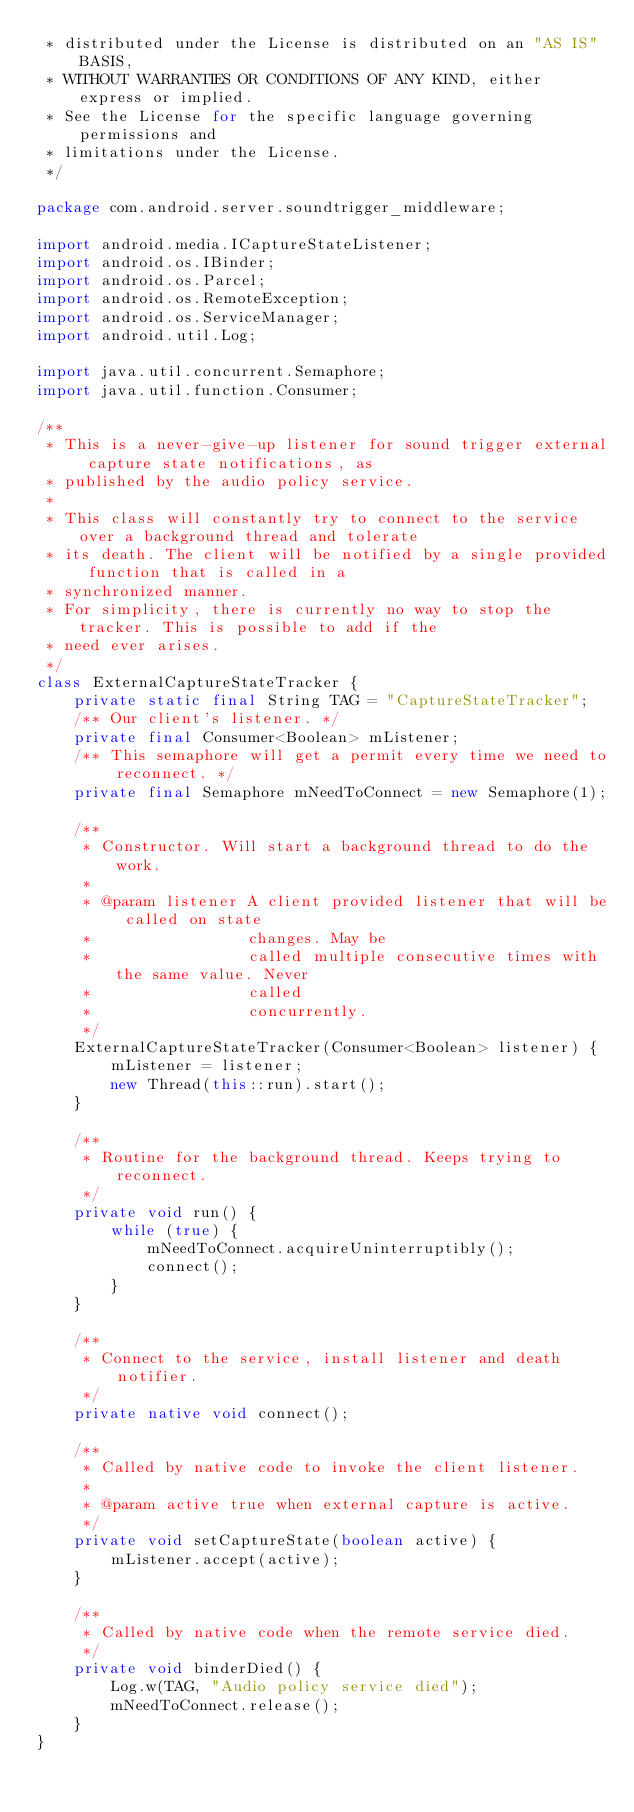<code> <loc_0><loc_0><loc_500><loc_500><_Java_> * distributed under the License is distributed on an "AS IS" BASIS,
 * WITHOUT WARRANTIES OR CONDITIONS OF ANY KIND, either express or implied.
 * See the License for the specific language governing permissions and
 * limitations under the License.
 */

package com.android.server.soundtrigger_middleware;

import android.media.ICaptureStateListener;
import android.os.IBinder;
import android.os.Parcel;
import android.os.RemoteException;
import android.os.ServiceManager;
import android.util.Log;

import java.util.concurrent.Semaphore;
import java.util.function.Consumer;

/**
 * This is a never-give-up listener for sound trigger external capture state notifications, as
 * published by the audio policy service.
 *
 * This class will constantly try to connect to the service over a background thread and tolerate
 * its death. The client will be notified by a single provided function that is called in a
 * synchronized manner.
 * For simplicity, there is currently no way to stop the tracker. This is possible to add if the
 * need ever arises.
 */
class ExternalCaptureStateTracker {
    private static final String TAG = "CaptureStateTracker";
    /** Our client's listener. */
    private final Consumer<Boolean> mListener;
    /** This semaphore will get a permit every time we need to reconnect. */
    private final Semaphore mNeedToConnect = new Semaphore(1);

    /**
     * Constructor. Will start a background thread to do the work.
     *
     * @param listener A client provided listener that will be called on state
     *                 changes. May be
     *                 called multiple consecutive times with the same value. Never
     *                 called
     *                 concurrently.
     */
    ExternalCaptureStateTracker(Consumer<Boolean> listener) {
        mListener = listener;
        new Thread(this::run).start();
    }

    /**
     * Routine for the background thread. Keeps trying to reconnect.
     */
    private void run() {
        while (true) {
            mNeedToConnect.acquireUninterruptibly();
            connect();
        }
    }

    /**
     * Connect to the service, install listener and death notifier.
     */
    private native void connect();

    /**
     * Called by native code to invoke the client listener.
     *
     * @param active true when external capture is active.
     */
    private void setCaptureState(boolean active) {
        mListener.accept(active);
    }

    /**
     * Called by native code when the remote service died.
     */
    private void binderDied() {
        Log.w(TAG, "Audio policy service died");
        mNeedToConnect.release();
    }
}
</code> 